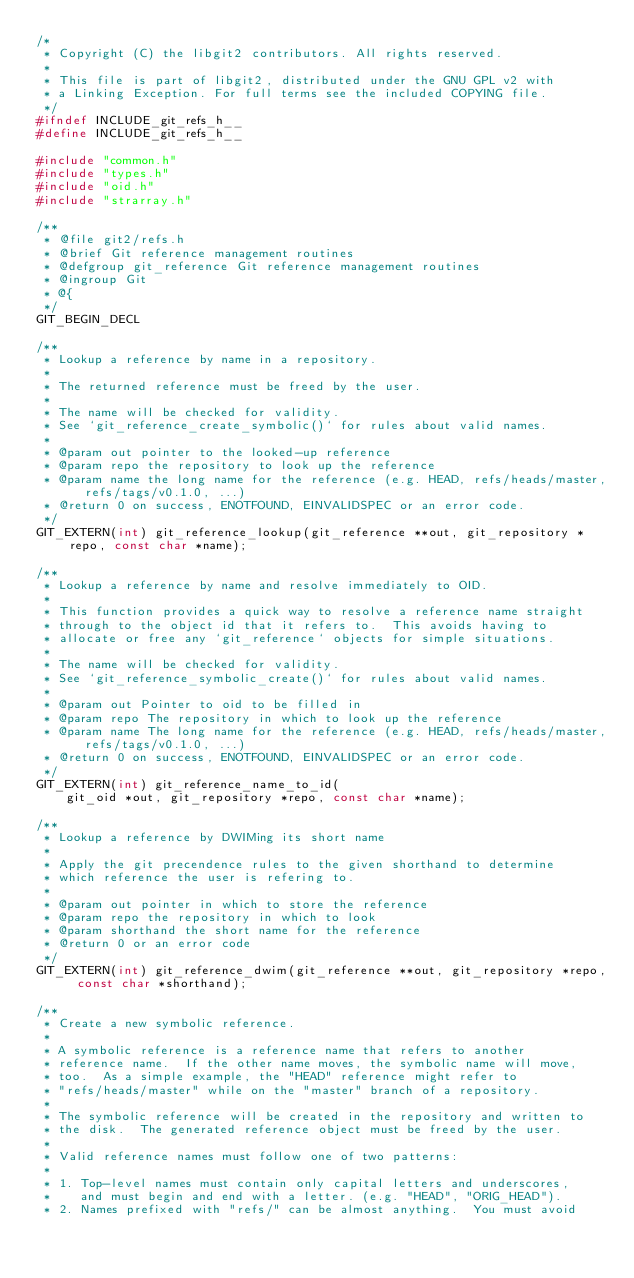Convert code to text. <code><loc_0><loc_0><loc_500><loc_500><_C_>/*
 * Copyright (C) the libgit2 contributors. All rights reserved.
 *
 * This file is part of libgit2, distributed under the GNU GPL v2 with
 * a Linking Exception. For full terms see the included COPYING file.
 */
#ifndef INCLUDE_git_refs_h__
#define INCLUDE_git_refs_h__

#include "common.h"
#include "types.h"
#include "oid.h"
#include "strarray.h"

/**
 * @file git2/refs.h
 * @brief Git reference management routines
 * @defgroup git_reference Git reference management routines
 * @ingroup Git
 * @{
 */
GIT_BEGIN_DECL

/**
 * Lookup a reference by name in a repository.
 *
 * The returned reference must be freed by the user.
 *
 * The name will be checked for validity.
 * See `git_reference_create_symbolic()` for rules about valid names.
 *
 * @param out pointer to the looked-up reference
 * @param repo the repository to look up the reference
 * @param name the long name for the reference (e.g. HEAD, refs/heads/master, refs/tags/v0.1.0, ...)
 * @return 0 on success, ENOTFOUND, EINVALIDSPEC or an error code.
 */
GIT_EXTERN(int) git_reference_lookup(git_reference **out, git_repository *repo, const char *name);

/**
 * Lookup a reference by name and resolve immediately to OID.
 *
 * This function provides a quick way to resolve a reference name straight
 * through to the object id that it refers to.  This avoids having to
 * allocate or free any `git_reference` objects for simple situations.
 *
 * The name will be checked for validity.
 * See `git_reference_symbolic_create()` for rules about valid names.
 *
 * @param out Pointer to oid to be filled in
 * @param repo The repository in which to look up the reference
 * @param name The long name for the reference (e.g. HEAD, refs/heads/master, refs/tags/v0.1.0, ...)
 * @return 0 on success, ENOTFOUND, EINVALIDSPEC or an error code.
 */
GIT_EXTERN(int) git_reference_name_to_id(
	git_oid *out, git_repository *repo, const char *name);

/**
 * Lookup a reference by DWIMing its short name
 *
 * Apply the git precendence rules to the given shorthand to determine
 * which reference the user is refering to.
 *
 * @param out pointer in which to store the reference
 * @param repo the repository in which to look
 * @param shorthand the short name for the reference
 * @return 0 or an error code
 */
GIT_EXTERN(int) git_reference_dwim(git_reference **out, git_repository *repo, const char *shorthand);

/**
 * Create a new symbolic reference.
 *
 * A symbolic reference is a reference name that refers to another
 * reference name.  If the other name moves, the symbolic name will move,
 * too.  As a simple example, the "HEAD" reference might refer to
 * "refs/heads/master" while on the "master" branch of a repository.
 *
 * The symbolic reference will be created in the repository and written to
 * the disk.  The generated reference object must be freed by the user.
 *
 * Valid reference names must follow one of two patterns:
 *
 * 1. Top-level names must contain only capital letters and underscores,
 *    and must begin and end with a letter. (e.g. "HEAD", "ORIG_HEAD").
 * 2. Names prefixed with "refs/" can be almost anything.  You must avoid</code> 